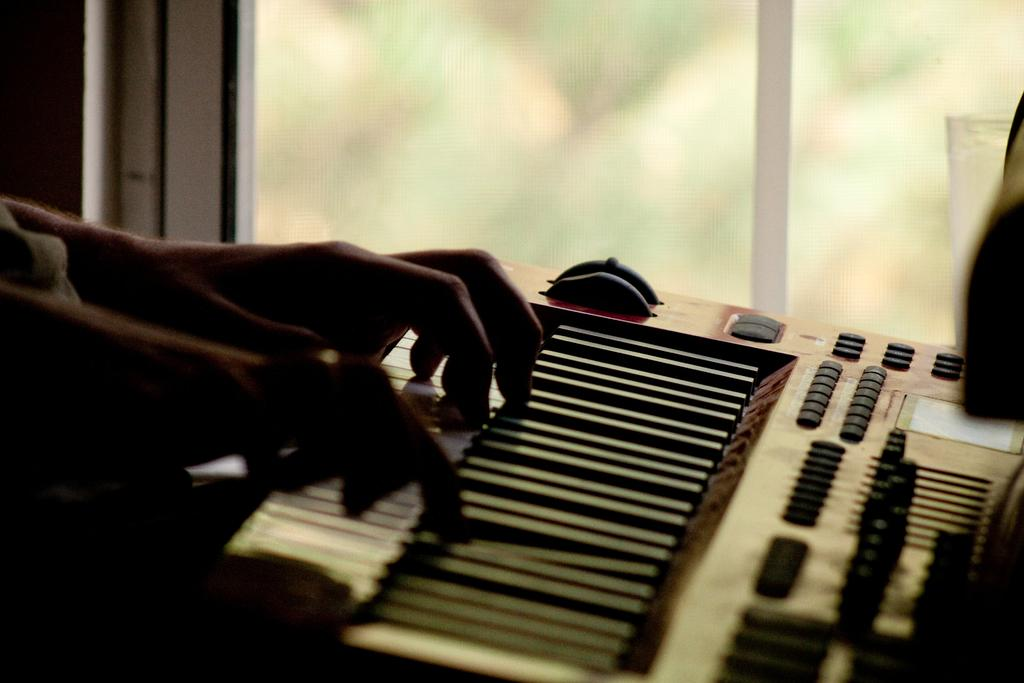What musical instrument is present in the image? There is a piano in the image. What is the person in the image doing with the piano? A person is playing the piano. What can be seen in the background of the image? There is a glass window in the background of the image. What direction is the soda being poured in the image? There is no soda present in the image, so it cannot be determined in which direction it might be poured. 